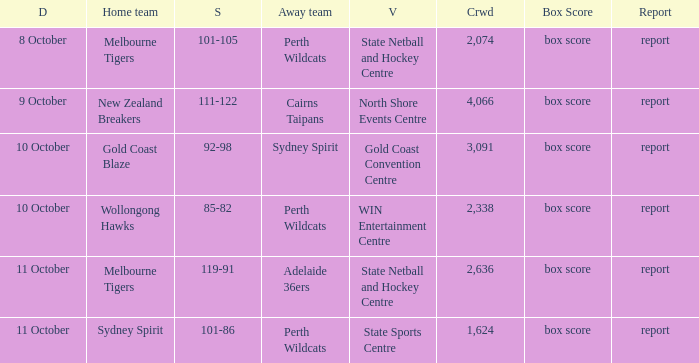What was the number of the crowd when the Wollongong Hawks were the home team? 2338.0. 